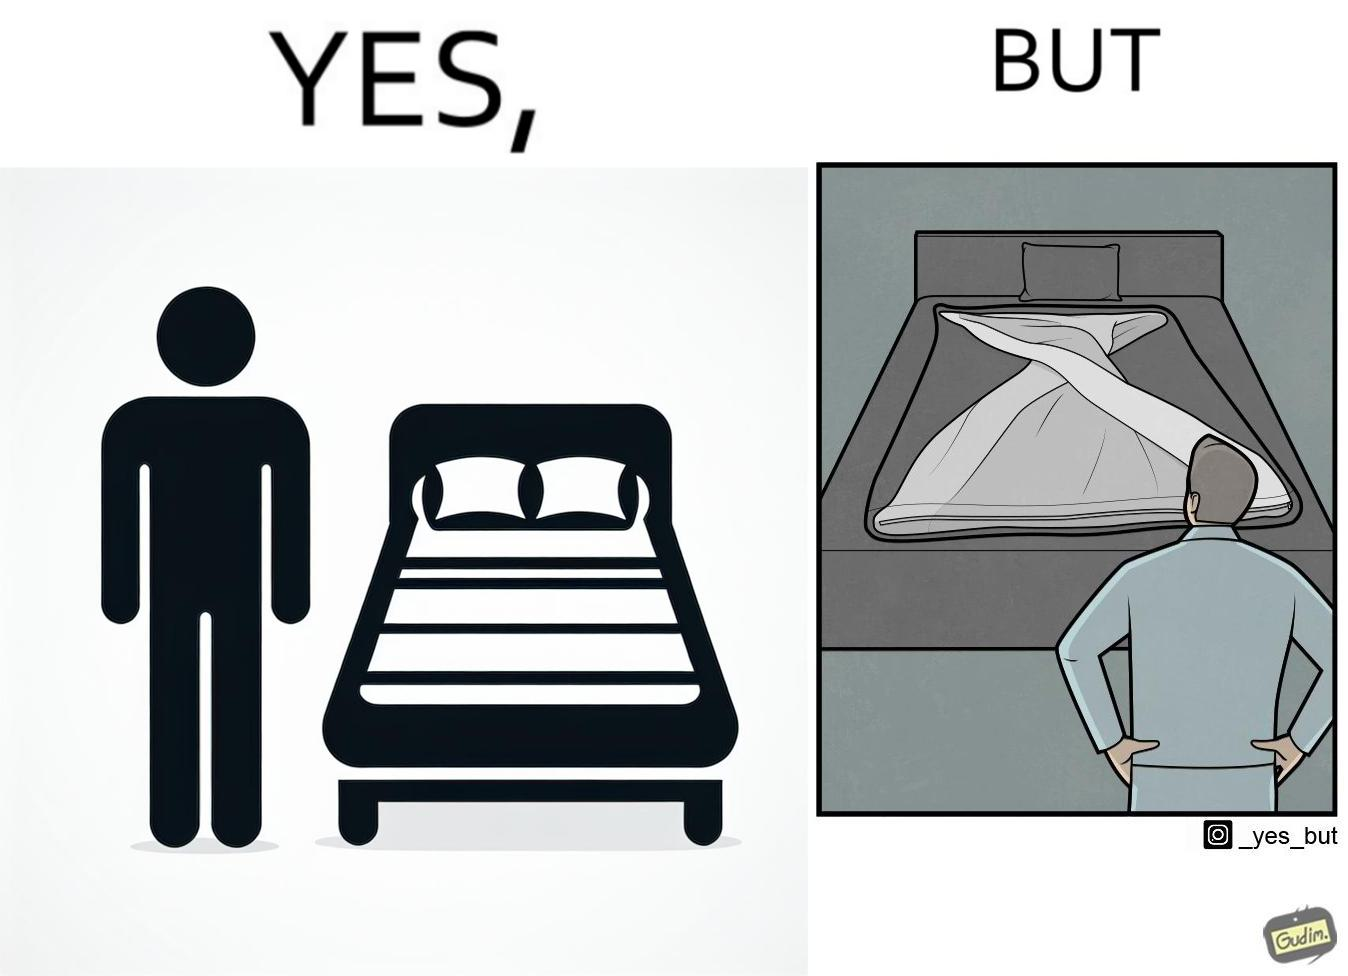Why is this image considered satirical? The image is funny because while the bed seems to be well made with the blanket on top, the actual blanket inside the blanket cover is twisted and not properly set. 